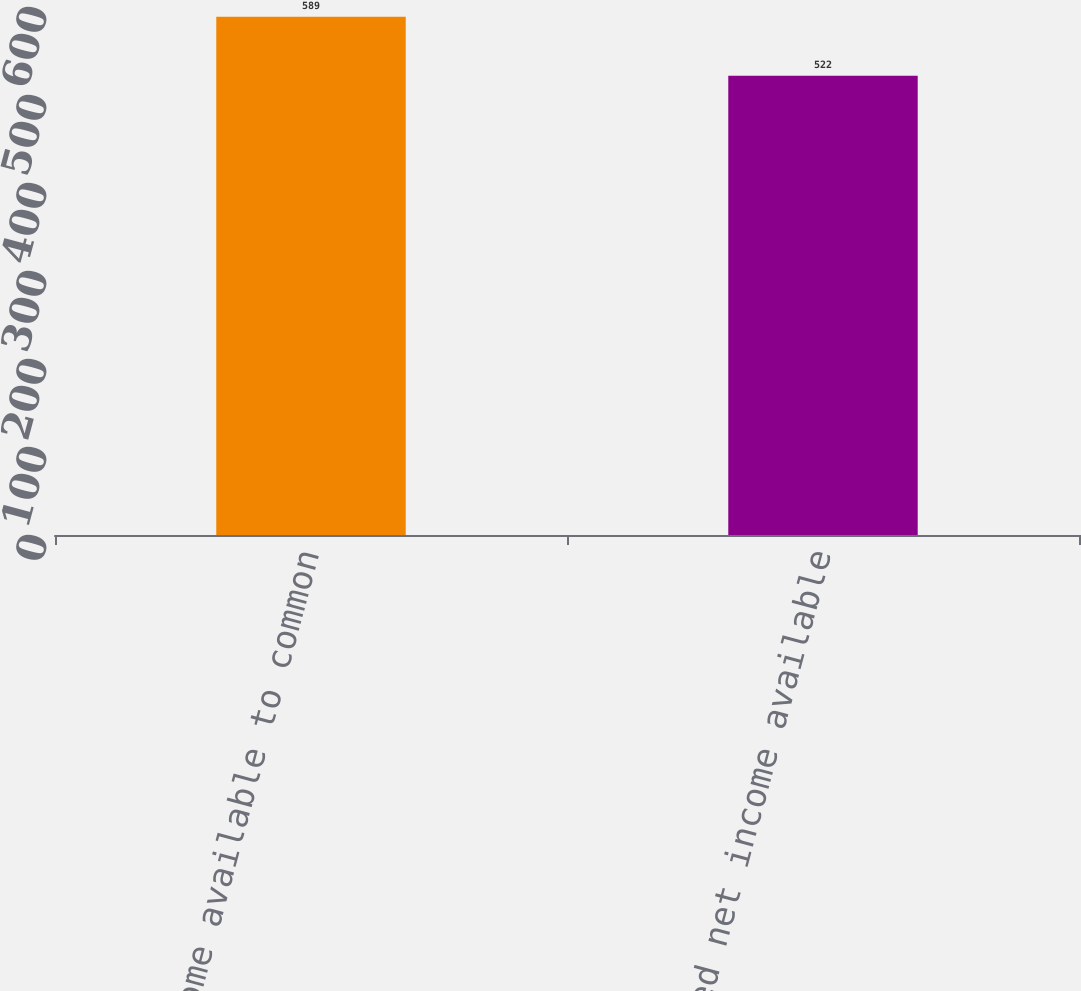Convert chart. <chart><loc_0><loc_0><loc_500><loc_500><bar_chart><fcel>Net income available to common<fcel>Adjusted net income available<nl><fcel>589<fcel>522<nl></chart> 